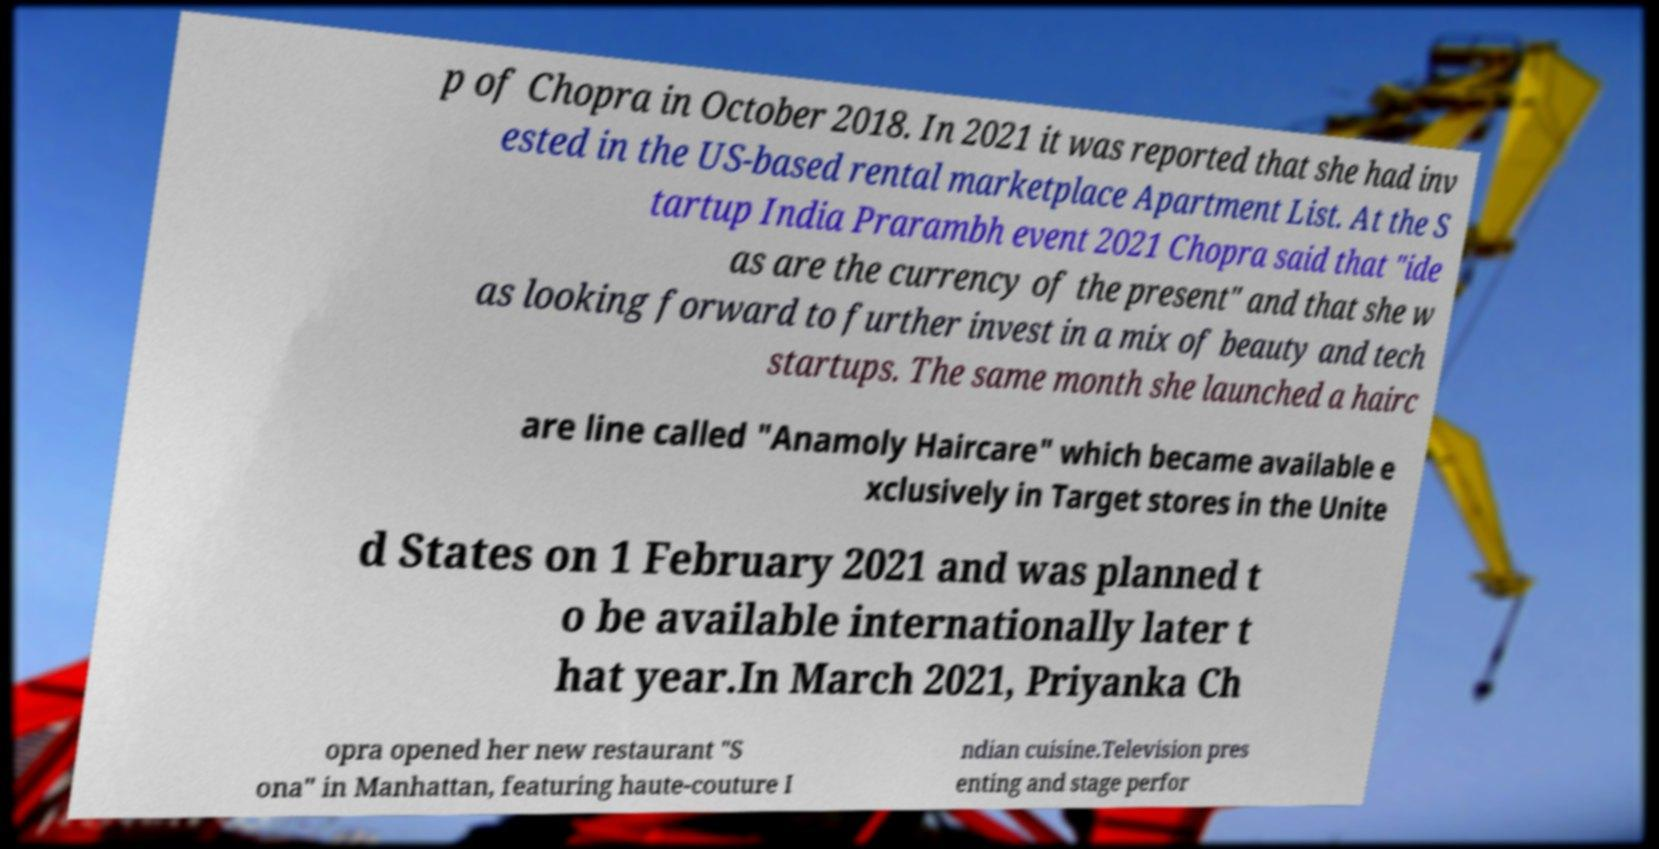There's text embedded in this image that I need extracted. Can you transcribe it verbatim? p of Chopra in October 2018. In 2021 it was reported that she had inv ested in the US-based rental marketplace Apartment List. At the S tartup India Prarambh event 2021 Chopra said that "ide as are the currency of the present" and that she w as looking forward to further invest in a mix of beauty and tech startups. The same month she launched a hairc are line called "Anamoly Haircare" which became available e xclusively in Target stores in the Unite d States on 1 February 2021 and was planned t o be available internationally later t hat year.In March 2021, Priyanka Ch opra opened her new restaurant "S ona" in Manhattan, featuring haute-couture I ndian cuisine.Television pres enting and stage perfor 